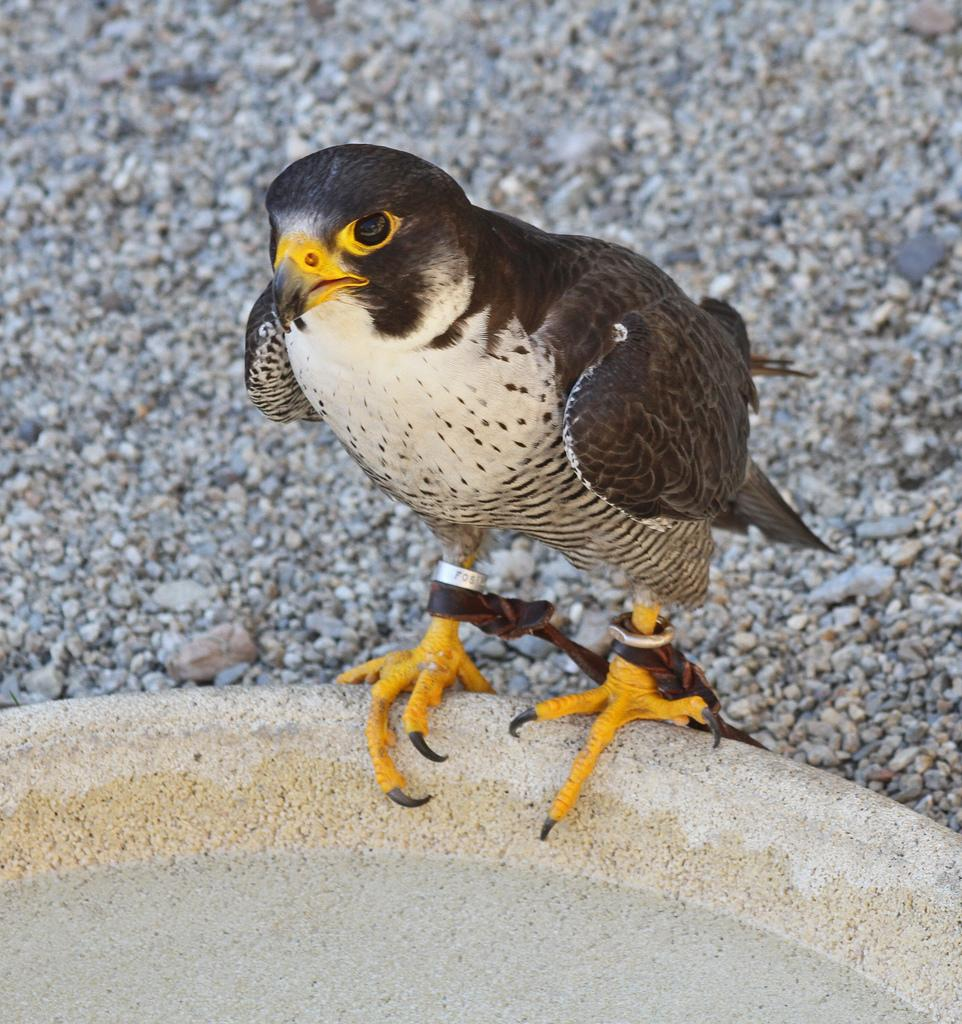What type of animal can be seen in the image? There is a bird in the image. What is visible beneath the bird? The ground is visible in the image. What can be found on the ground in the image? There are stones on the ground in the image. What is located at the bottom of the image? There is an object at the bottom of the image. What does the writer's sister say about the wind in the image? There is no writer, sister, or mention of wind in the image. 